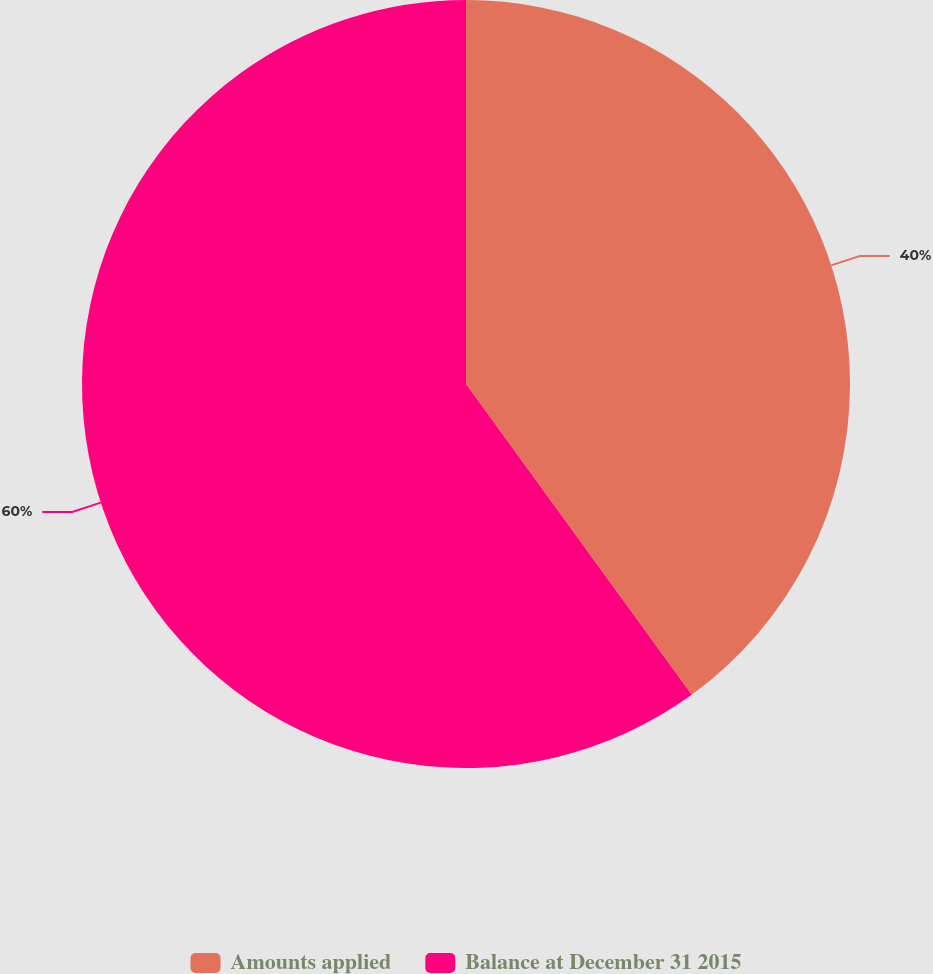Convert chart. <chart><loc_0><loc_0><loc_500><loc_500><pie_chart><fcel>Amounts applied<fcel>Balance at December 31 2015<nl><fcel>40.0%<fcel>60.0%<nl></chart> 